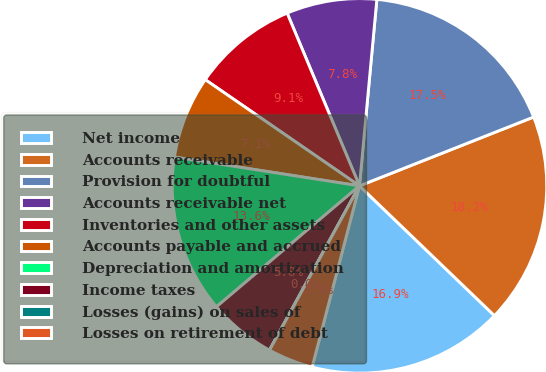Convert chart. <chart><loc_0><loc_0><loc_500><loc_500><pie_chart><fcel>Net income<fcel>Accounts receivable<fcel>Provision for doubtful<fcel>Accounts receivable net<fcel>Inventories and other assets<fcel>Accounts payable and accrued<fcel>Depreciation and amortization<fcel>Income taxes<fcel>Losses (gains) on sales of<fcel>Losses on retirement of debt<nl><fcel>16.88%<fcel>18.18%<fcel>17.53%<fcel>7.79%<fcel>9.09%<fcel>7.14%<fcel>13.63%<fcel>5.85%<fcel>0.01%<fcel>3.9%<nl></chart> 